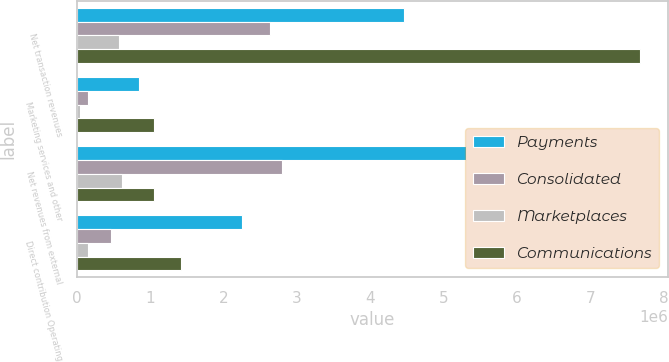Convert chart to OTSL. <chart><loc_0><loc_0><loc_500><loc_500><stacked_bar_chart><ecel><fcel>Net transaction revenues<fcel>Marketing services and other<fcel>Net revenues from external<fcel>Direct contribution Operating<nl><fcel>Payments<fcel>4.46184e+06<fcel>849169<fcel>5.31101e+06<fcel>2.25192e+06<nl><fcel>Consolidated<fcel>2.64119e+06<fcel>154751<fcel>2.79594e+06<fcel>463382<nl><fcel>Marketplaces<fcel>575096<fcel>45307<fcel>620403<fcel>157702<nl><fcel>Communications<fcel>7.67814e+06<fcel>1.04923e+06<fcel>1.04923e+06<fcel>1.41624e+06<nl></chart> 